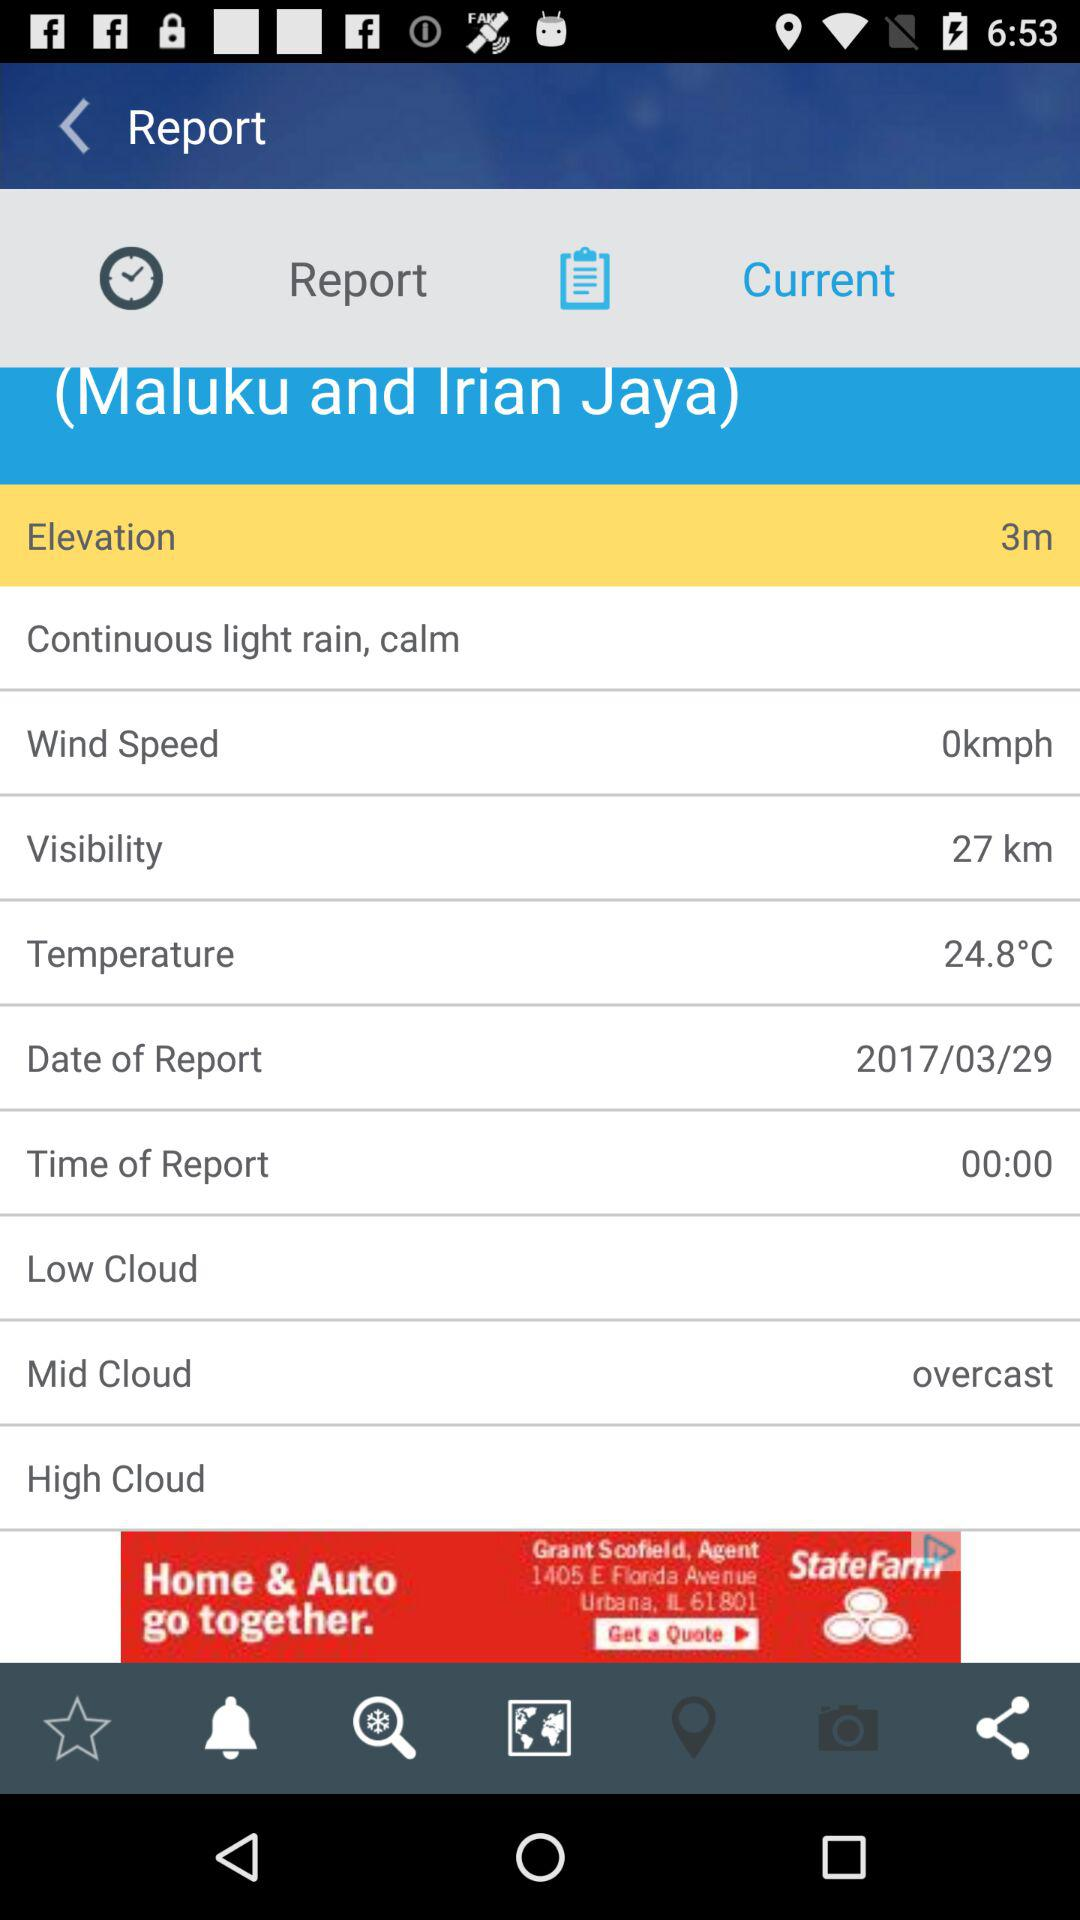Which tab is selected? The selected tab is "Current". 